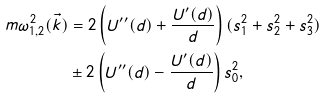<formula> <loc_0><loc_0><loc_500><loc_500>m \omega _ { 1 , 2 } ^ { 2 } ( \vec { k } ) & = 2 \left ( U ^ { \prime \prime } ( d ) + \frac { U ^ { \prime } ( d ) } { d } \right ) ( s _ { 1 } ^ { 2 } + s _ { 2 } ^ { 2 } + s _ { 3 } ^ { 2 } ) \\ & \pm 2 \left ( U ^ { \prime \prime } ( d ) - \frac { U ^ { \prime } ( d ) } { d } \right ) s _ { 0 } ^ { 2 } ,</formula> 